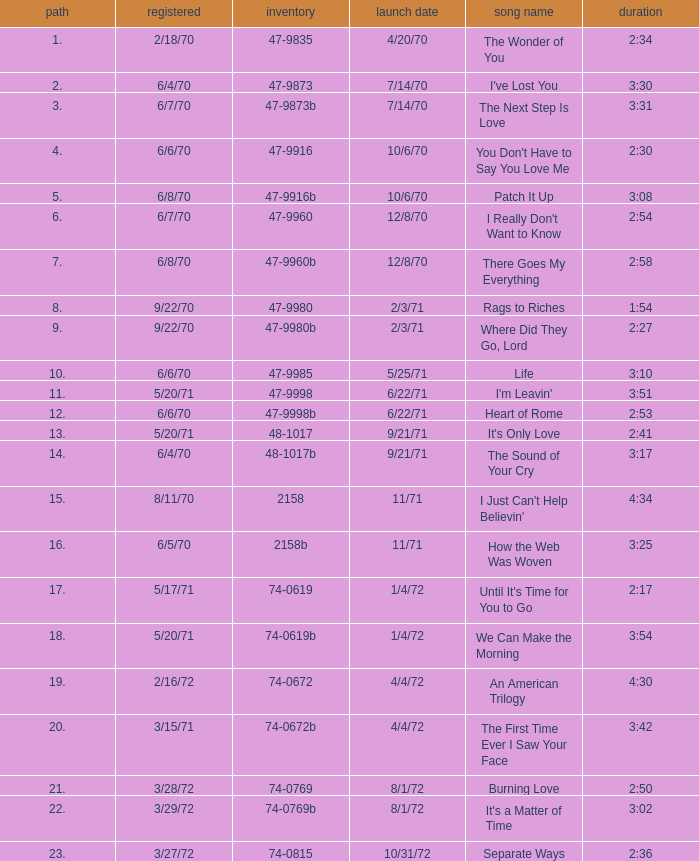What is Heart of Rome's catalogue number? 47-9998b. 